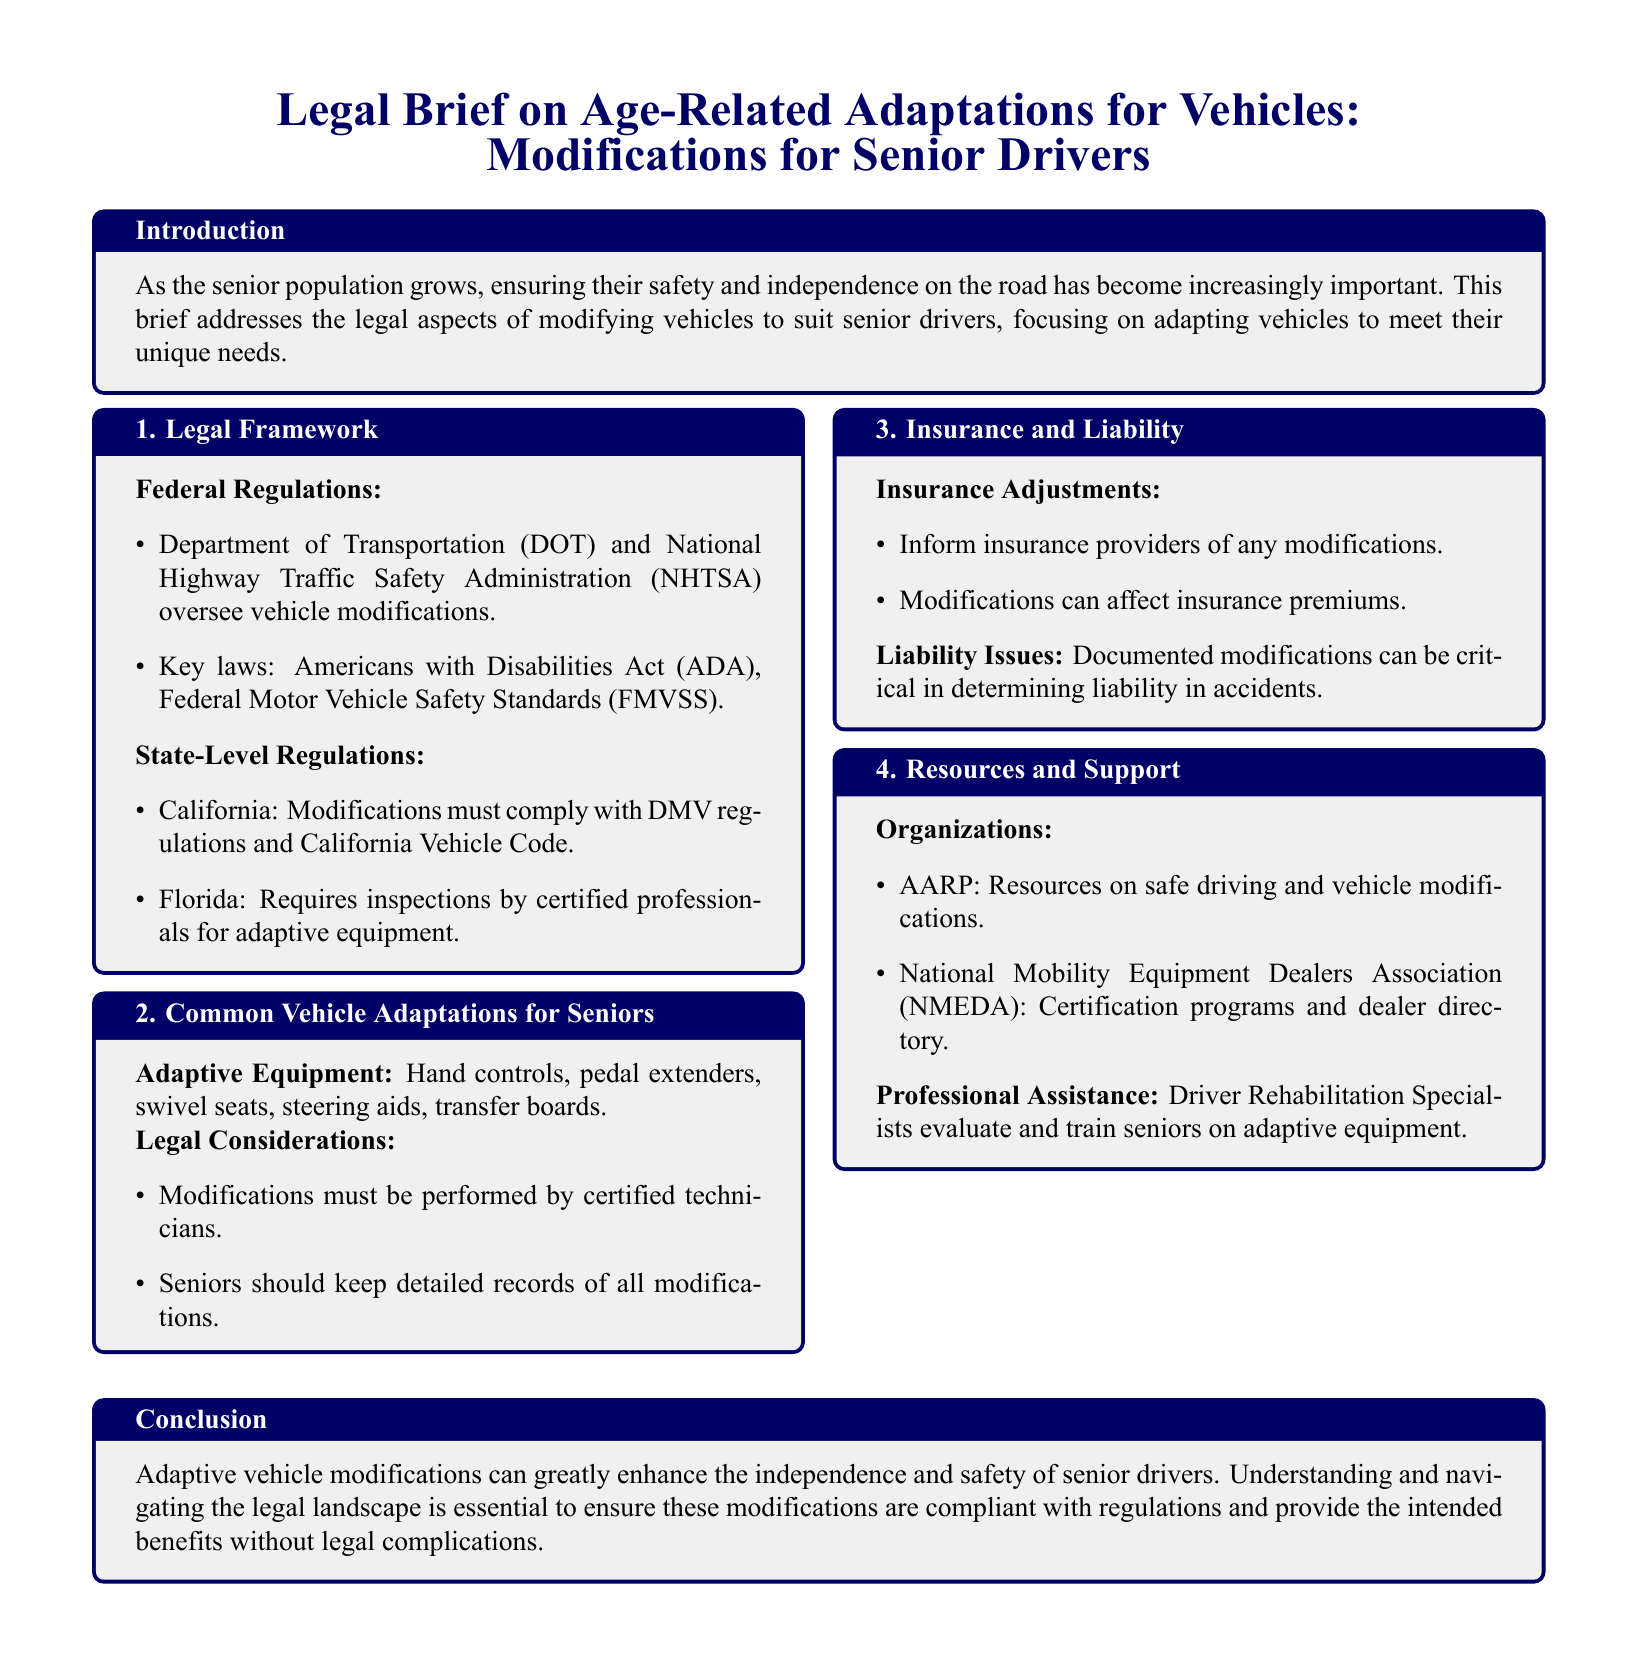What is the main focus of the brief? The introduction states the brief focuses on the legal aspects of modifying vehicles to suit senior drivers.
Answer: Legal aspects of modifying vehicles for senior drivers What federal agency oversees vehicle modifications? The document states the Department of Transportation (DOT) and National Highway Traffic Safety Administration (NHTSA) oversee vehicle modifications.
Answer: Department of Transportation (DOT) Which state requires inspections by certified professionals for adaptive equipment? Florida is mentioned as requiring inspections by certified professionals for adaptive equipment in the state-level regulations section.
Answer: Florida What is a common adaptive equipment mentioned for seniors? The section on common vehicle adaptations lists hand controls as one example of adaptive equipment.
Answer: Hand controls What must modifications be performed by? The legal considerations part mentions modifications must be performed by certified technicians.
Answer: Certified technicians What organization provides resources on safe driving? AARP is identified as an organization that provides resources on safe driving and vehicle modifications.
Answer: AARP How can vehicle modifications affect insurance? The insurance adjustments section mentions that modifications can affect insurance premiums.
Answer: Insurance premiums What is essential to ensure modifications are compliant? The conclusion emphasizes that understanding and navigating the legal landscape is essential to ensure compliance.
Answer: Understanding the legal landscape 